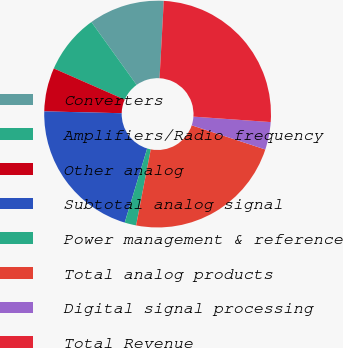Convert chart to OTSL. <chart><loc_0><loc_0><loc_500><loc_500><pie_chart><fcel>Converters<fcel>Amplifiers/Radio frequency<fcel>Other analog<fcel>Subtotal analog signal<fcel>Power management & reference<fcel>Total analog products<fcel>Digital signal processing<fcel>Total Revenue<nl><fcel>10.79%<fcel>8.49%<fcel>6.21%<fcel>20.7%<fcel>1.65%<fcel>22.98%<fcel>3.93%<fcel>25.26%<nl></chart> 